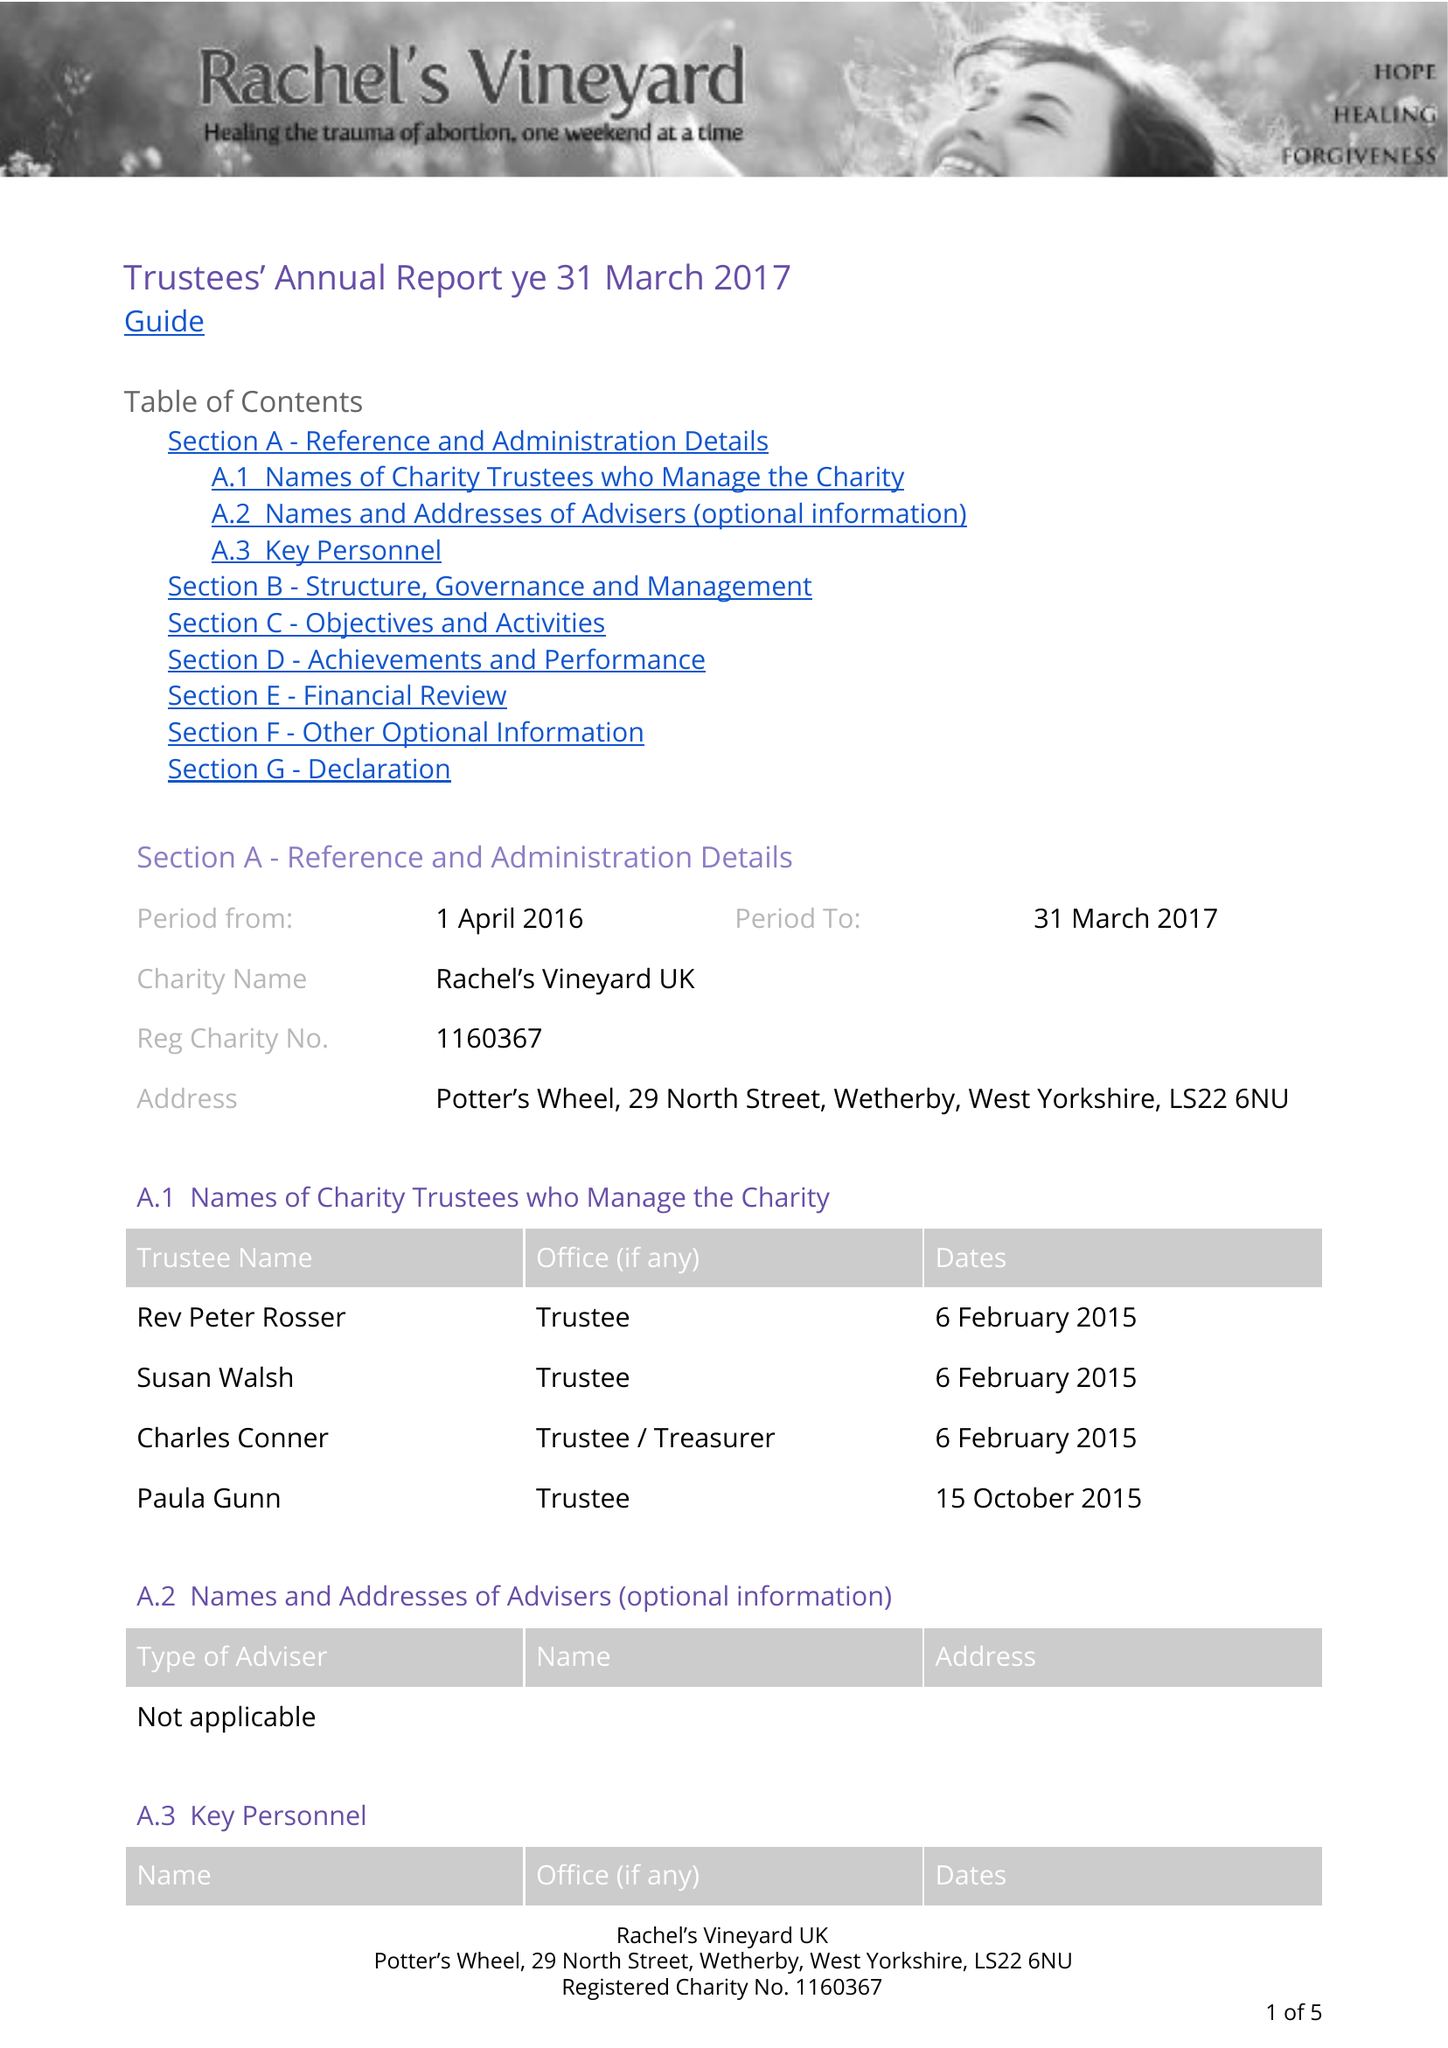What is the value for the report_date?
Answer the question using a single word or phrase. 2017-03-31 